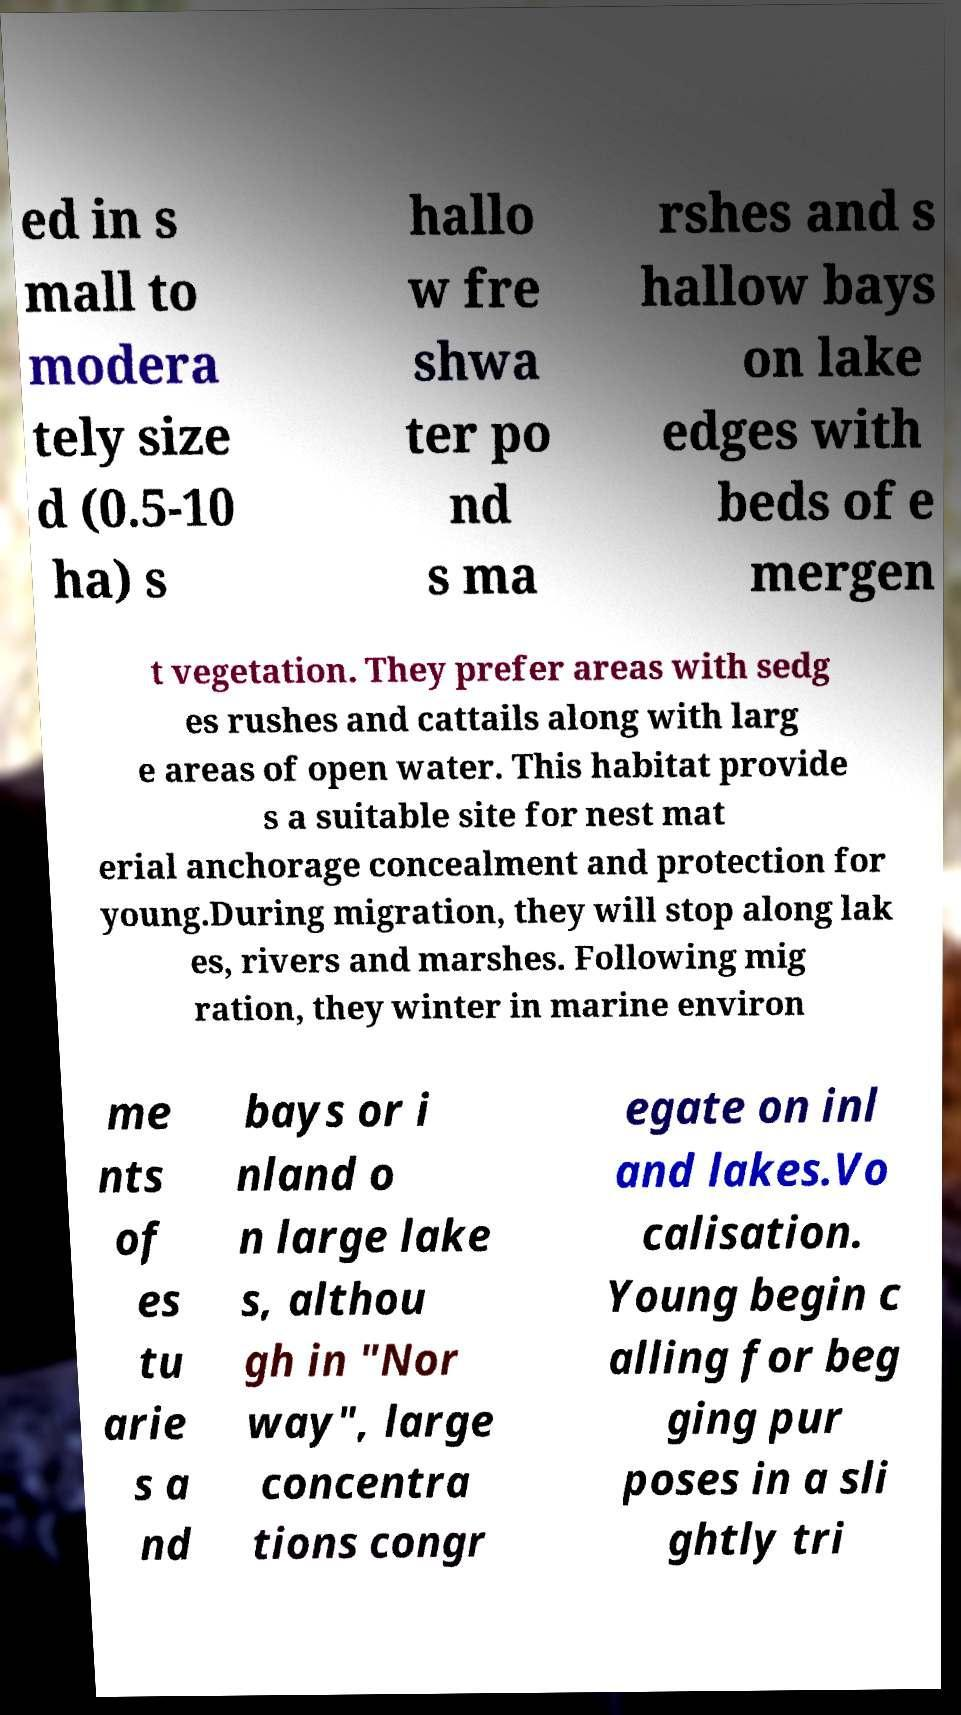There's text embedded in this image that I need extracted. Can you transcribe it verbatim? ed in s mall to modera tely size d (0.5-10 ha) s hallo w fre shwa ter po nd s ma rshes and s hallow bays on lake edges with beds of e mergen t vegetation. They prefer areas with sedg es rushes and cattails along with larg e areas of open water. This habitat provide s a suitable site for nest mat erial anchorage concealment and protection for young.During migration, they will stop along lak es, rivers and marshes. Following mig ration, they winter in marine environ me nts of es tu arie s a nd bays or i nland o n large lake s, althou gh in "Nor way", large concentra tions congr egate on inl and lakes.Vo calisation. Young begin c alling for beg ging pur poses in a sli ghtly tri 